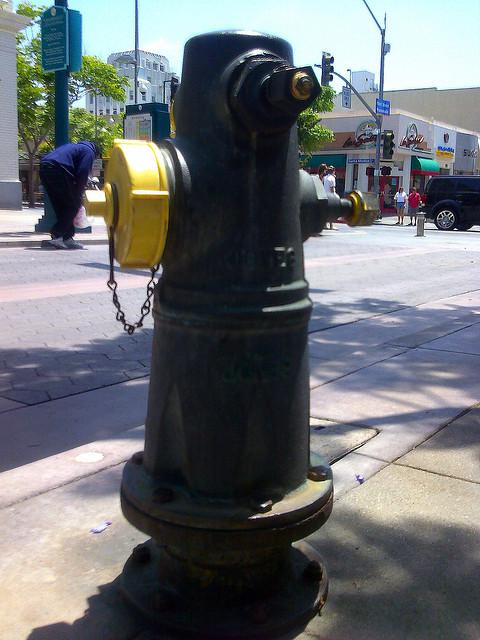What is inside the green and yellow object on the sidewalk? water 